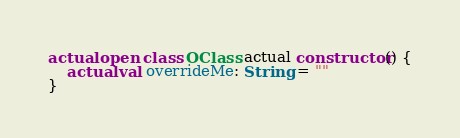<code> <loc_0><loc_0><loc_500><loc_500><_Kotlin_>actual open class OClass actual constructor() {
    actual val overrideMe: String = ""
}</code> 